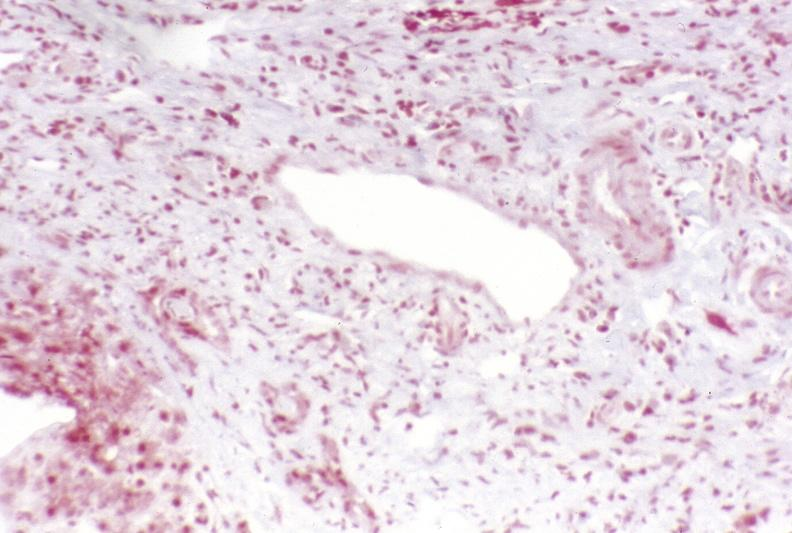s liver present?
Answer the question using a single word or phrase. Yes 